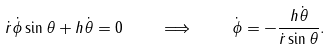Convert formula to latex. <formula><loc_0><loc_0><loc_500><loc_500>\dot { r } \dot { \phi } \sin \theta + h \dot { \theta } = 0 \quad \Longrightarrow \quad \dot { \phi } = - \frac { h \dot { \theta } } { \dot { r } \sin \theta } .</formula> 